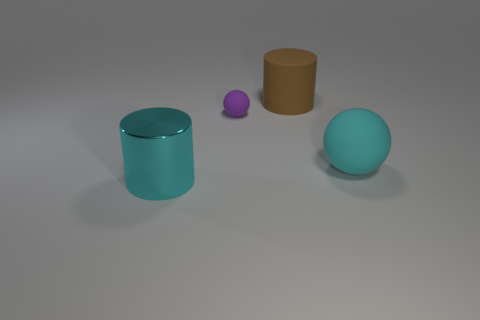Add 4 brown cylinders. How many objects exist? 8 Add 2 large cyan rubber things. How many large cyan rubber things are left? 3 Add 3 tiny brown cylinders. How many tiny brown cylinders exist? 3 Subtract 0 cyan cubes. How many objects are left? 4 Subtract all large purple matte cylinders. Subtract all tiny matte balls. How many objects are left? 3 